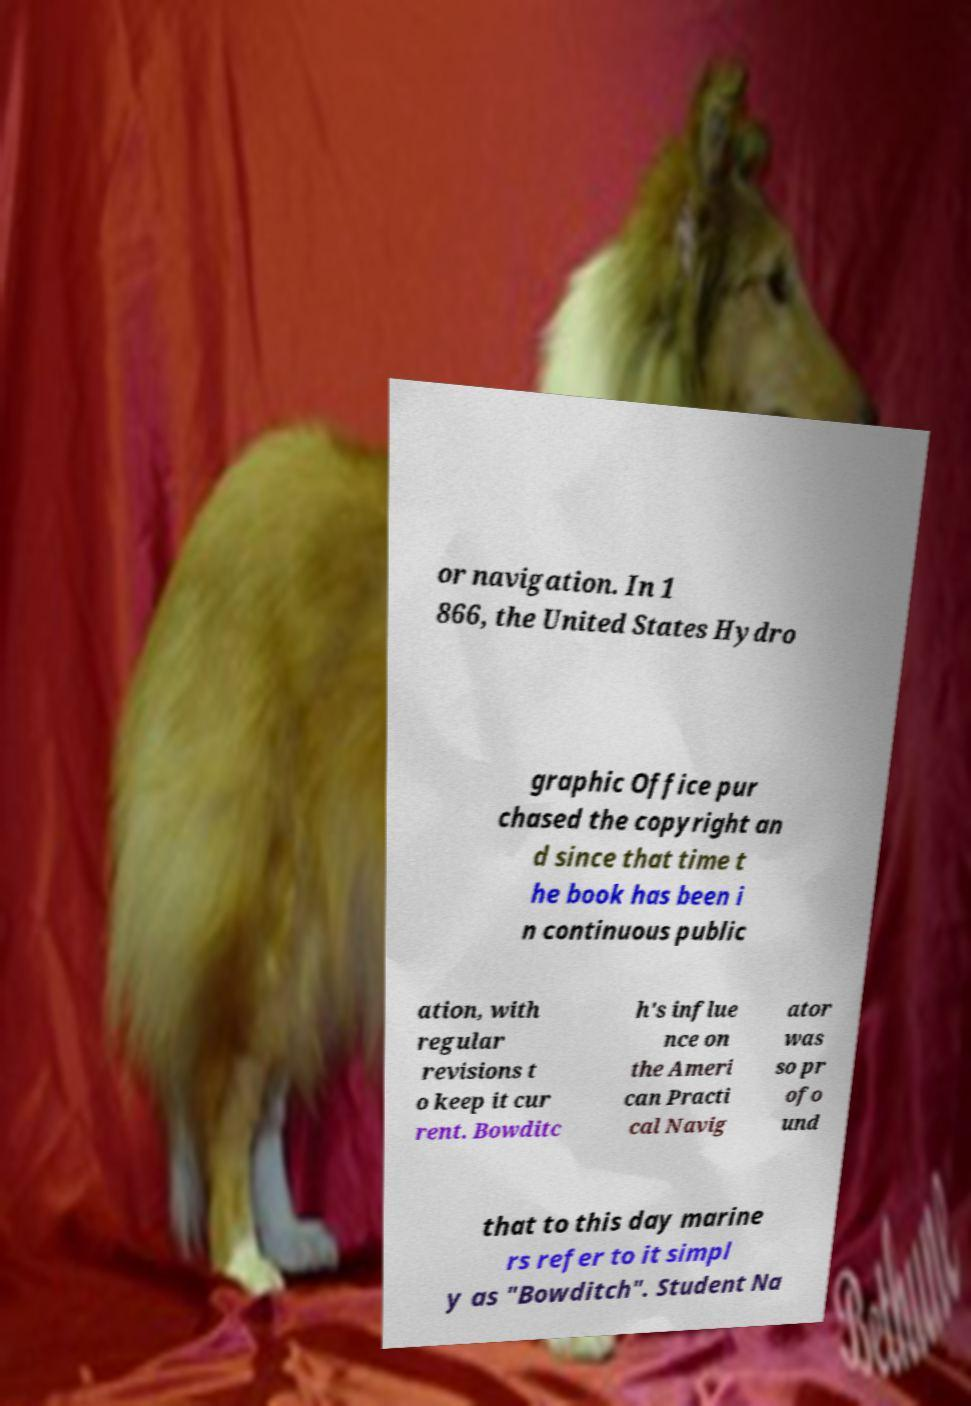For documentation purposes, I need the text within this image transcribed. Could you provide that? or navigation. In 1 866, the United States Hydro graphic Office pur chased the copyright an d since that time t he book has been i n continuous public ation, with regular revisions t o keep it cur rent. Bowditc h's influe nce on the Ameri can Practi cal Navig ator was so pr ofo und that to this day marine rs refer to it simpl y as "Bowditch". Student Na 